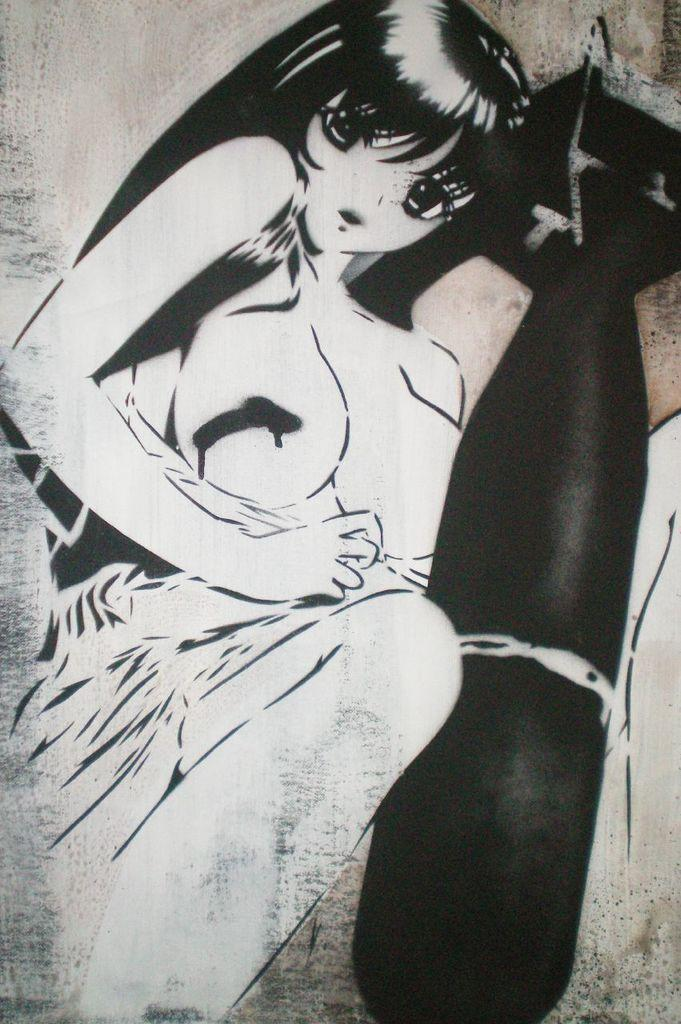What is depicted in the image? There is a sketch of a lady in the image. Can you describe the object on the paper in the image? Unfortunately, the facts provided do not give any information about the object on the paper. What type of quince is being used to create the current in the image? There is no quince or current present in the image; it features a sketch of a lady and an object on the paper. 